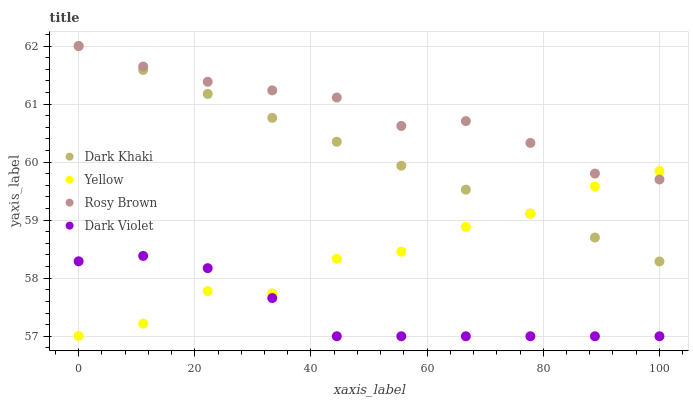Does Dark Violet have the minimum area under the curve?
Answer yes or no. Yes. Does Rosy Brown have the maximum area under the curve?
Answer yes or no. Yes. Does Rosy Brown have the minimum area under the curve?
Answer yes or no. No. Does Dark Violet have the maximum area under the curve?
Answer yes or no. No. Is Dark Khaki the smoothest?
Answer yes or no. Yes. Is Yellow the roughest?
Answer yes or no. Yes. Is Rosy Brown the smoothest?
Answer yes or no. No. Is Rosy Brown the roughest?
Answer yes or no. No. Does Dark Violet have the lowest value?
Answer yes or no. Yes. Does Rosy Brown have the lowest value?
Answer yes or no. No. Does Rosy Brown have the highest value?
Answer yes or no. Yes. Does Dark Violet have the highest value?
Answer yes or no. No. Is Dark Violet less than Rosy Brown?
Answer yes or no. Yes. Is Dark Khaki greater than Dark Violet?
Answer yes or no. Yes. Does Yellow intersect Rosy Brown?
Answer yes or no. Yes. Is Yellow less than Rosy Brown?
Answer yes or no. No. Is Yellow greater than Rosy Brown?
Answer yes or no. No. Does Dark Violet intersect Rosy Brown?
Answer yes or no. No. 